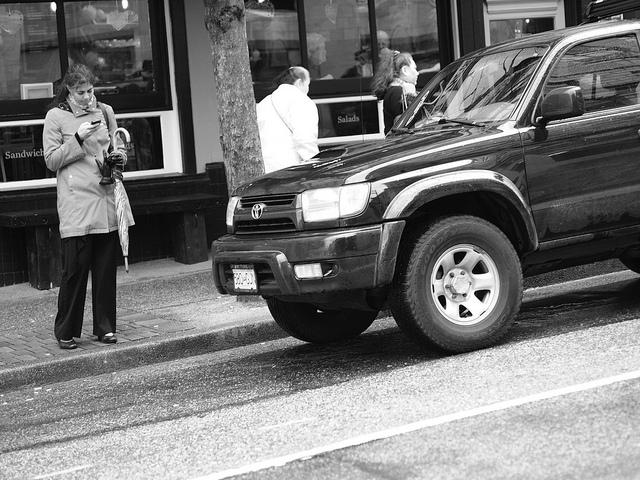Why is the woman looking down into her hand? phone 